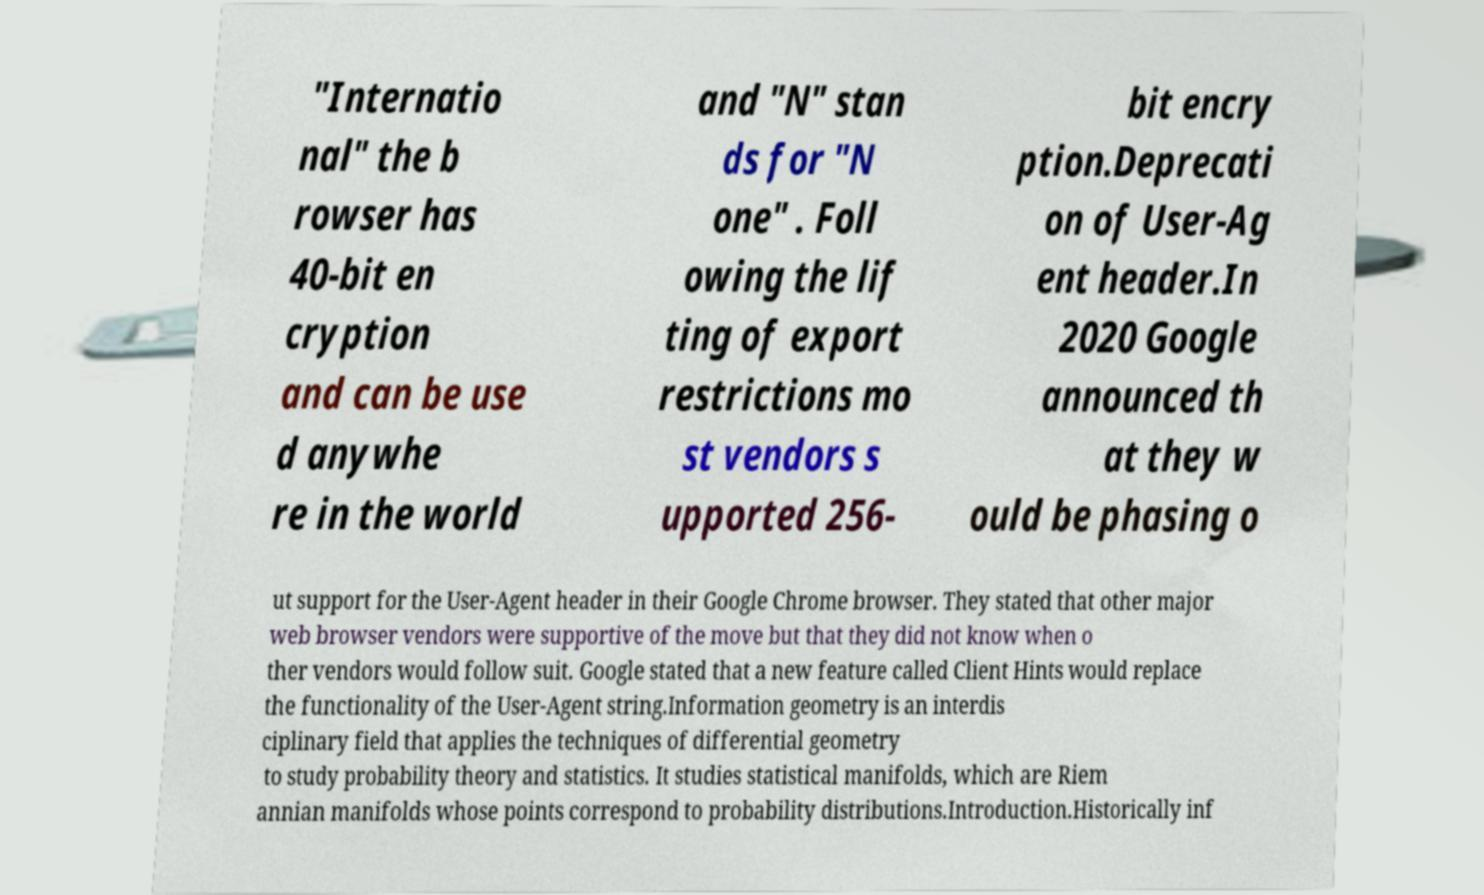Can you read and provide the text displayed in the image?This photo seems to have some interesting text. Can you extract and type it out for me? "Internatio nal" the b rowser has 40-bit en cryption and can be use d anywhe re in the world and "N" stan ds for "N one" . Foll owing the lif ting of export restrictions mo st vendors s upported 256- bit encry ption.Deprecati on of User-Ag ent header.In 2020 Google announced th at they w ould be phasing o ut support for the User-Agent header in their Google Chrome browser. They stated that other major web browser vendors were supportive of the move but that they did not know when o ther vendors would follow suit. Google stated that a new feature called Client Hints would replace the functionality of the User-Agent string.Information geometry is an interdis ciplinary field that applies the techniques of differential geometry to study probability theory and statistics. It studies statistical manifolds, which are Riem annian manifolds whose points correspond to probability distributions.Introduction.Historically inf 